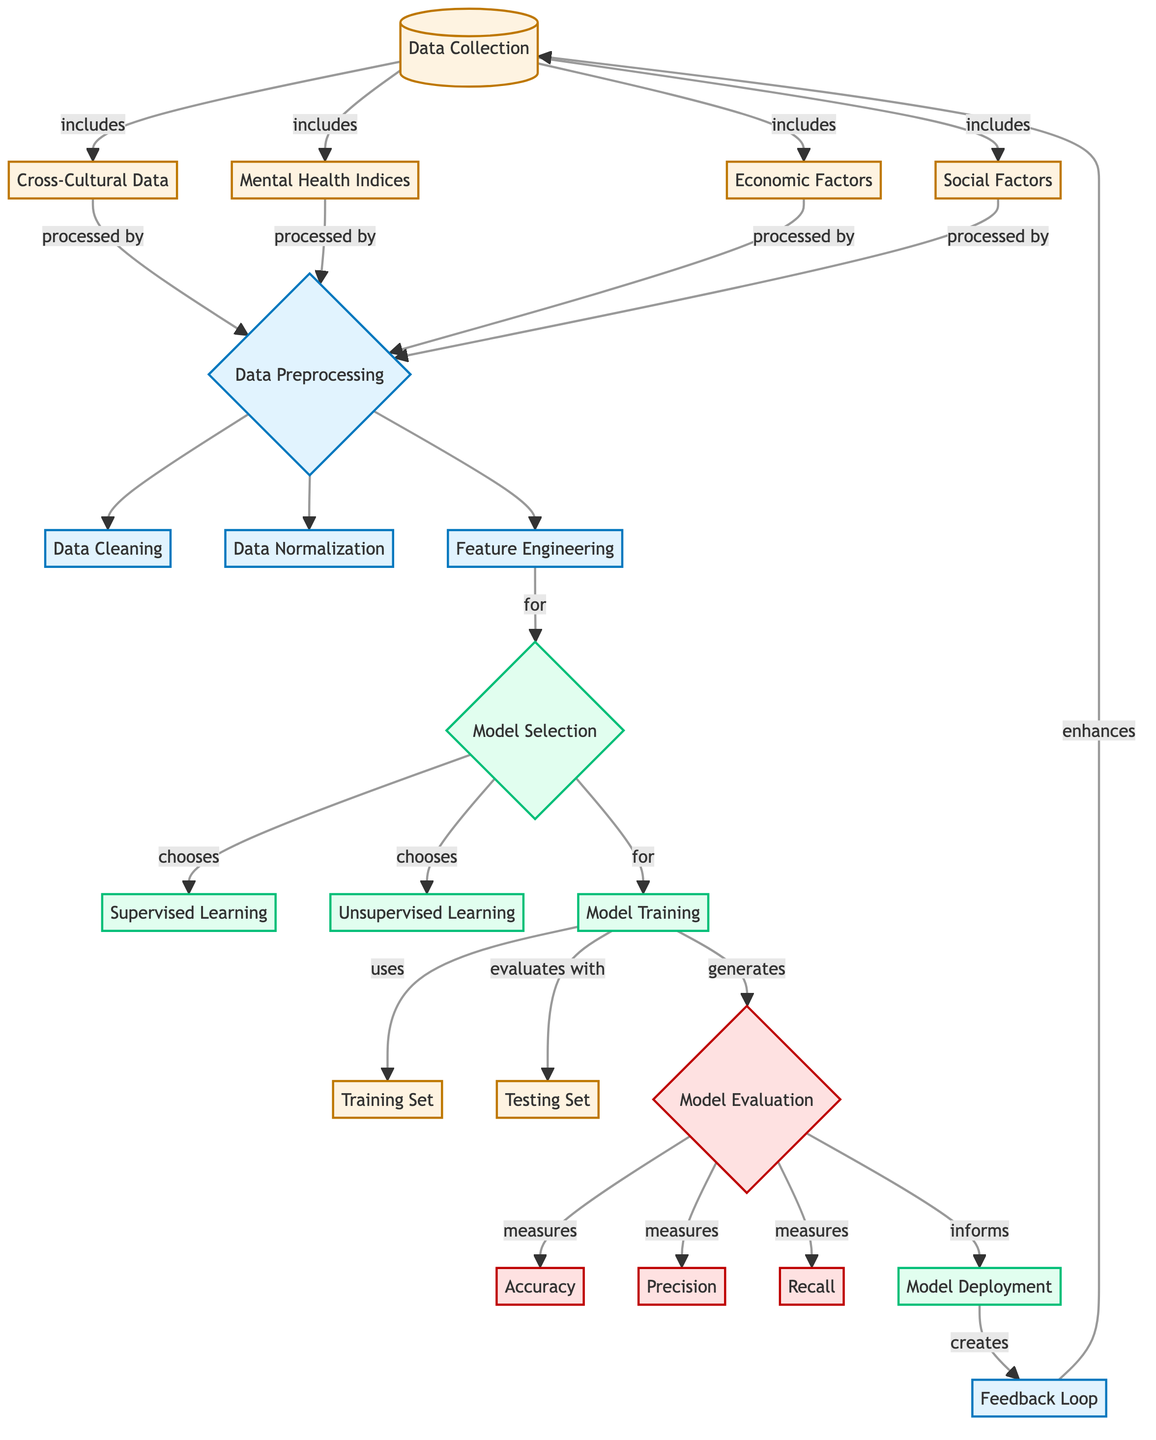What are the three main types of data collected? The diagram indicates that data collection includes cross-cultural data, mental health indices, and economic factors, alongside social factors.
Answer: Cross-Cultural Data, Mental Health Indices, Economic Factors, Social Factors What process follows data preprocessing? According to the diagram, after data preprocessing, the next steps are data cleaning, data normalization, and feature engineering.
Answer: Data Cleaning, Data Normalization, Feature Engineering Which learning approach is selected for model training? The diagram shows that model selection chooses between supervised learning and unsupervised learning for subsequent model training.
Answer: Supervised Learning, Unsupervised Learning How many evaluation metrics are used in model evaluation? The diagram lists three evaluation metrics: accuracy, precision, and recall, indicating that a total of three metrics are utilized.
Answer: Three What flows after model deployment? The diagram illustrates that following model deployment, a feedback loop is created that enhances data collection.
Answer: Feedback Loop Which step generates model evaluation? Model training evaluates the model with a testing set and generates model evaluation, according to the process depicted in the diagram.
Answer: Model Training What is the output of the feedback loop? The feedback loop enhances the data collection process, suggesting that the data collection is improved based on previous insights.
Answer: Enhances Data Collection What is the primary purpose of feature engineering? In the diagram, feature engineering is linked to model selection, indicating its primary purpose is to prepare features for choosing a model.
Answer: For Model Selection Which node connects directly to testing set? The diagram shows that model training uses the testing set, forming a direct connection between these two nodes.
Answer: Model Training 